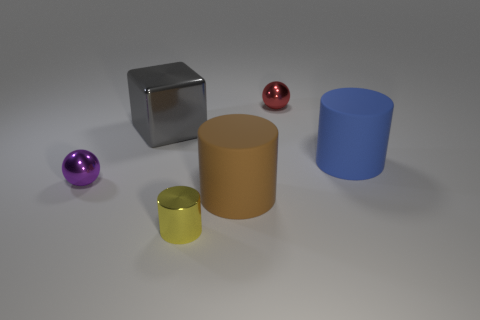Subtract all green spheres. Subtract all red blocks. How many spheres are left? 2 Add 1 tiny cyan shiny cylinders. How many objects exist? 7 Subtract all cubes. How many objects are left? 5 Subtract all matte things. Subtract all red metallic spheres. How many objects are left? 3 Add 5 big brown matte cylinders. How many big brown matte cylinders are left? 6 Add 6 tiny red balls. How many tiny red balls exist? 7 Subtract 0 red blocks. How many objects are left? 6 